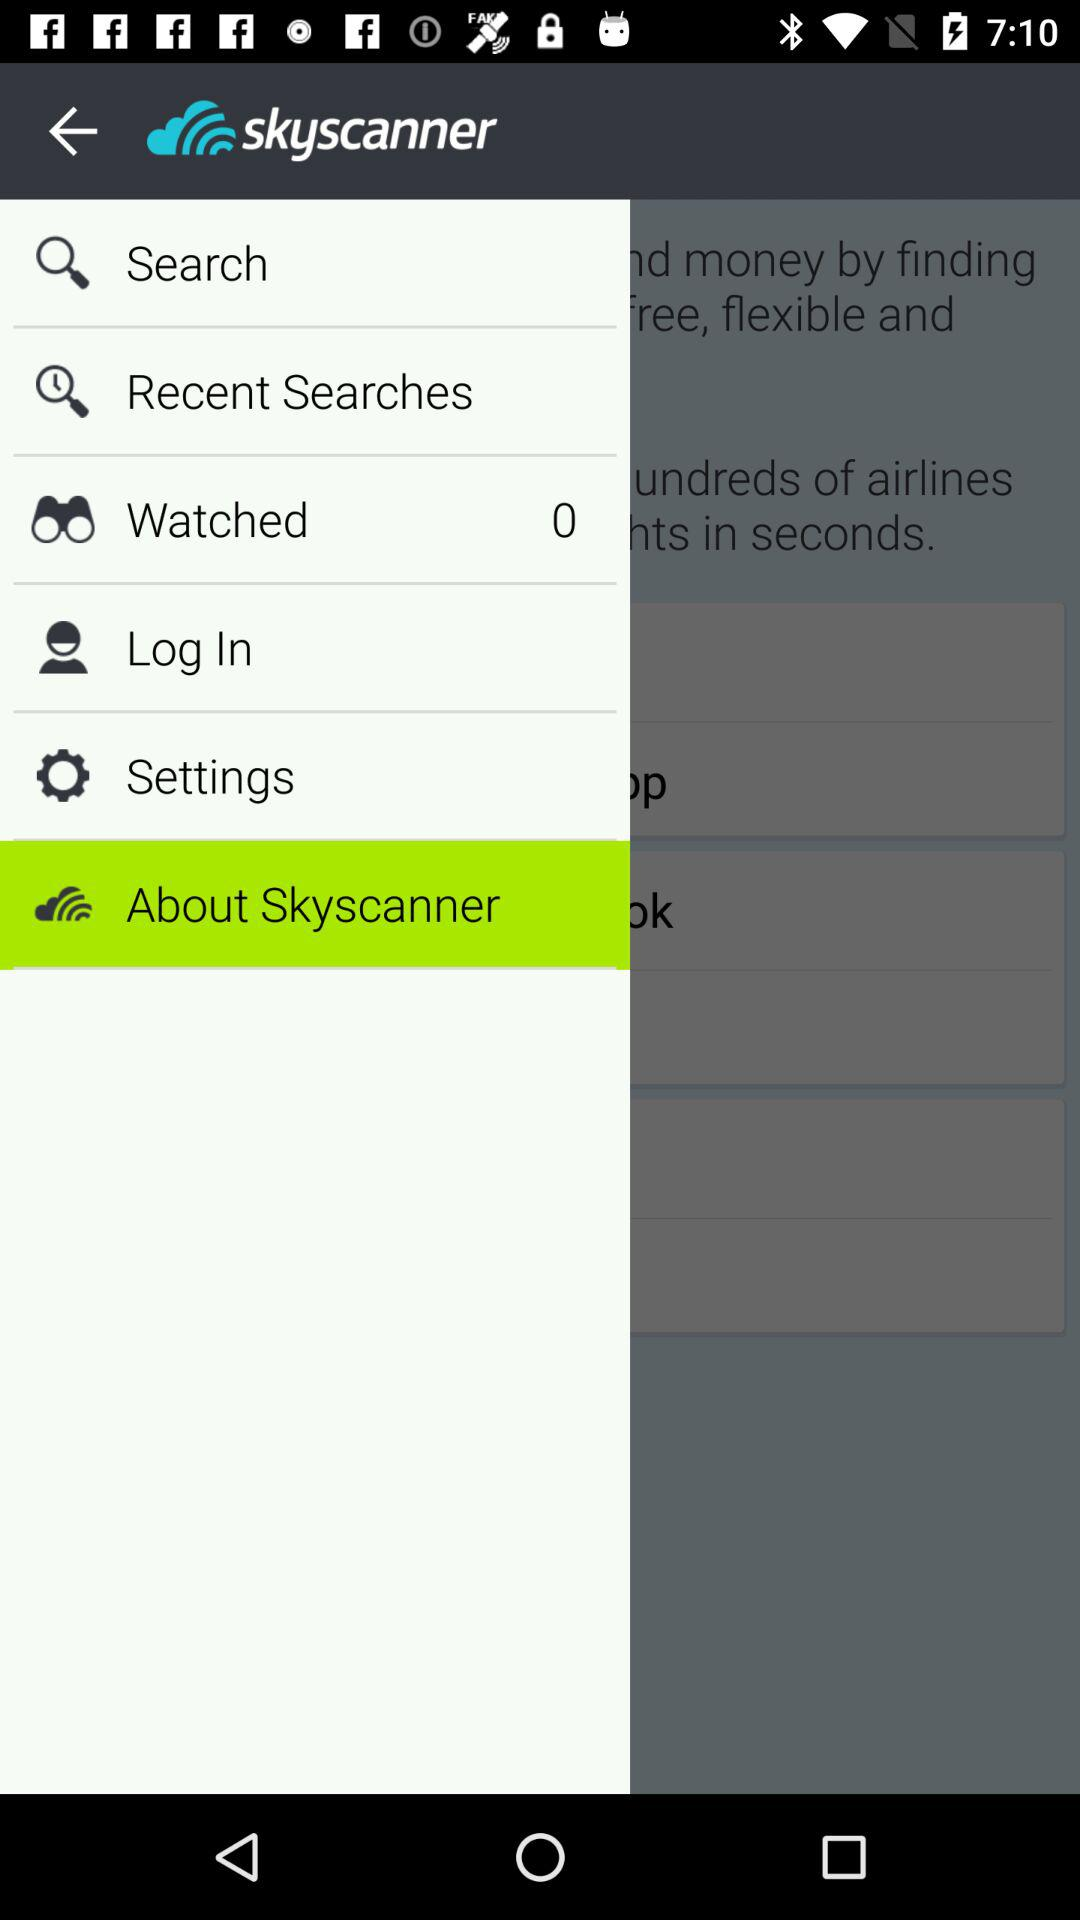What is the application name? The application name is "skyscanner". 